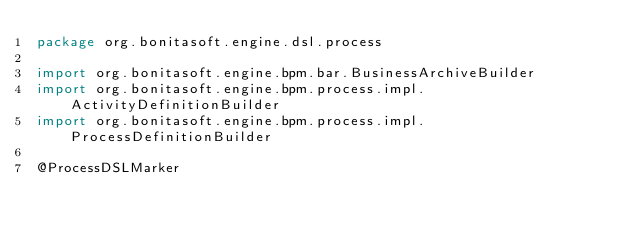Convert code to text. <code><loc_0><loc_0><loc_500><loc_500><_Kotlin_>package org.bonitasoft.engine.dsl.process

import org.bonitasoft.engine.bpm.bar.BusinessArchiveBuilder
import org.bonitasoft.engine.bpm.process.impl.ActivityDefinitionBuilder
import org.bonitasoft.engine.bpm.process.impl.ProcessDefinitionBuilder

@ProcessDSLMarker</code> 